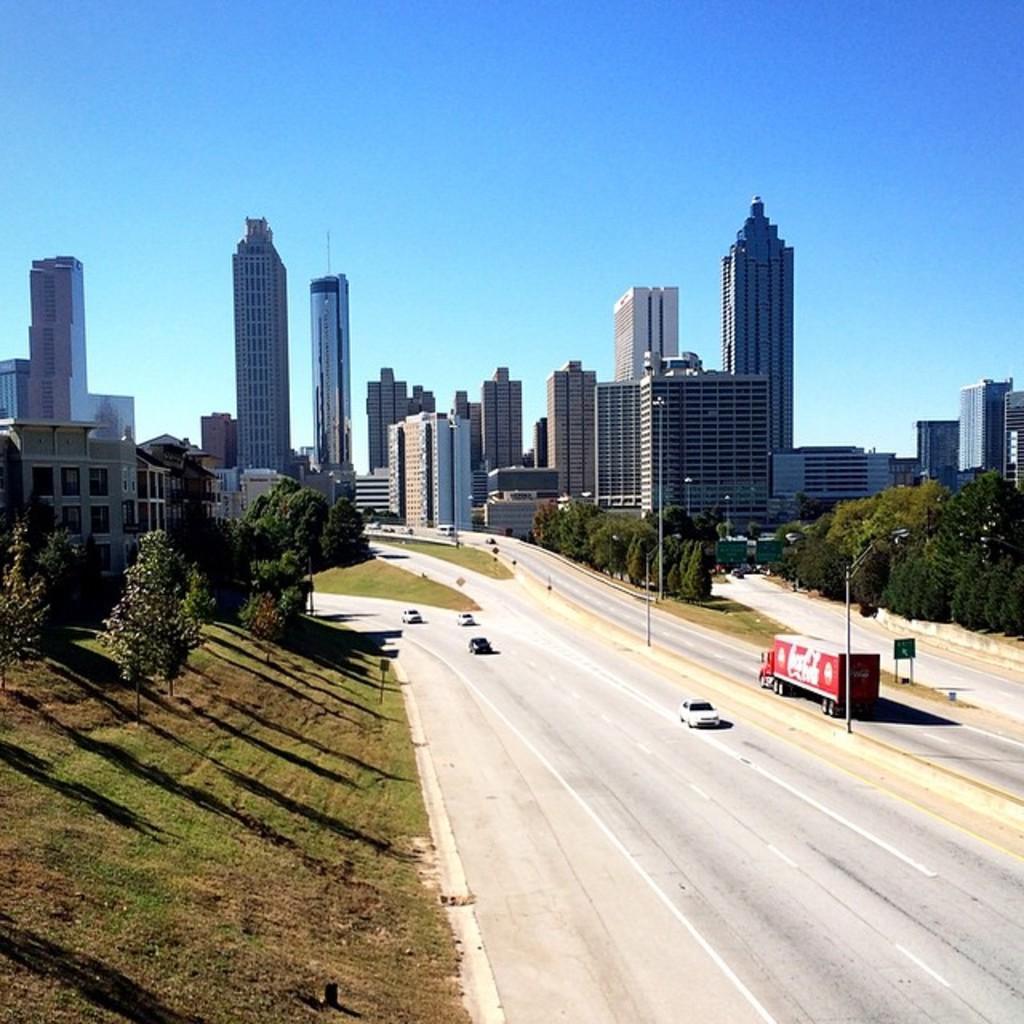Can you describe this image briefly? This is an outside view, in this image at the bottom there is a road. On the road there are some vehicles, on the left side there are some trees and grass. In the background there are some buildings, skyscrapers, trees, poles. At the top of the image there is sky. 